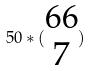Convert formula to latex. <formula><loc_0><loc_0><loc_500><loc_500>5 0 * ( \begin{matrix} 6 6 \\ 7 \end{matrix} )</formula> 